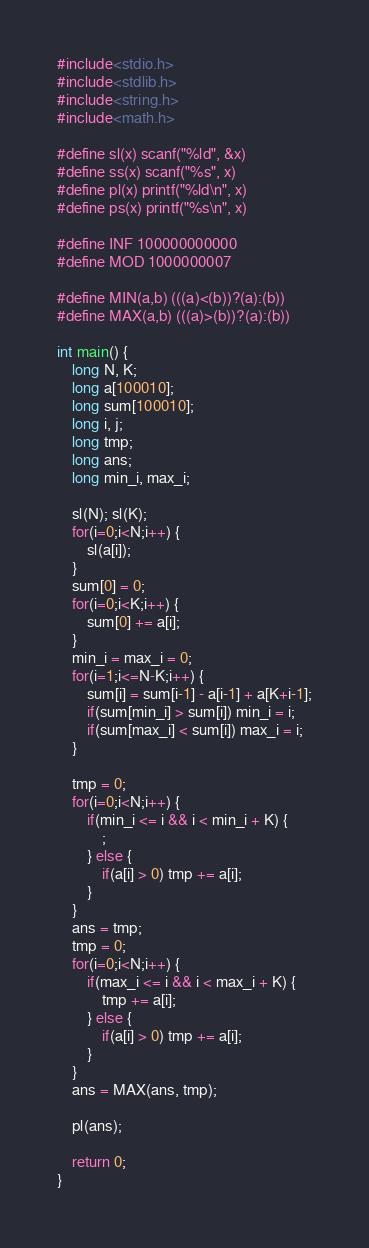<code> <loc_0><loc_0><loc_500><loc_500><_C_>#include<stdio.h>
#include<stdlib.h>
#include<string.h>
#include<math.h>
 
#define sl(x) scanf("%ld", &x)
#define ss(x) scanf("%s", x)
#define pl(x) printf("%ld\n", x)
#define ps(x) printf("%s\n", x)
 
#define INF 100000000000
#define MOD 1000000007
 
#define MIN(a,b) (((a)<(b))?(a):(b))
#define MAX(a,b) (((a)>(b))?(a):(b))

int main() {
	long N, K;
	long a[100010];
	long sum[100010];
	long i, j;
	long tmp;
	long ans;
	long min_i, max_i;
	
	sl(N); sl(K);
	for(i=0;i<N;i++) {
		sl(a[i]);
	}
	sum[0] = 0;
	for(i=0;i<K;i++) {
		sum[0] += a[i];
	}
	min_i = max_i = 0;
	for(i=1;i<=N-K;i++) {
		sum[i] = sum[i-1] - a[i-1] + a[K+i-1];
		if(sum[min_i] > sum[i]) min_i = i;
		if(sum[max_i] < sum[i]) max_i = i;
	}
	
	tmp = 0;
	for(i=0;i<N;i++) {
		if(min_i <= i && i < min_i + K) {
			;
		} else {
			if(a[i] > 0) tmp += a[i];
		}
	}
	ans = tmp;
	tmp = 0;
	for(i=0;i<N;i++) {
		if(max_i <= i && i < max_i + K) {
			tmp += a[i];
		} else {
			if(a[i] > 0) tmp += a[i];
		}
	}
	ans = MAX(ans, tmp);
	
	pl(ans);
	
	return 0;
}</code> 